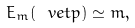<formula> <loc_0><loc_0><loc_500><loc_500>E _ { m } ( \ v e t { p } ) \simeq m ,</formula> 